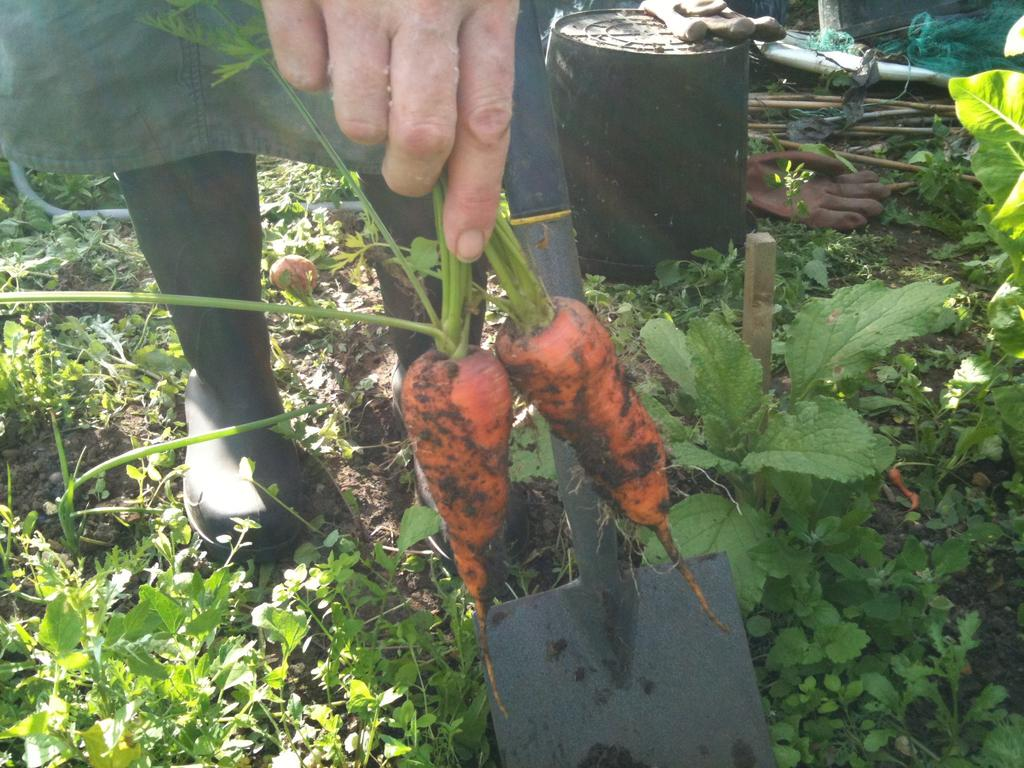Who or what is the main subject in the image? There is a person in the image. What is the person holding in the image? The person is holding carrots. What type of objects can be seen at the bottom of the image? There are many plants at the bottom of the image. What is located on the right side of the image? There is a small barrel on the right side of the image. What other items are present in the image? There are wooden sticks and gloves in the image. What type of quince is being used as a pocket in the image? There is no quince or pocket present in the image. 